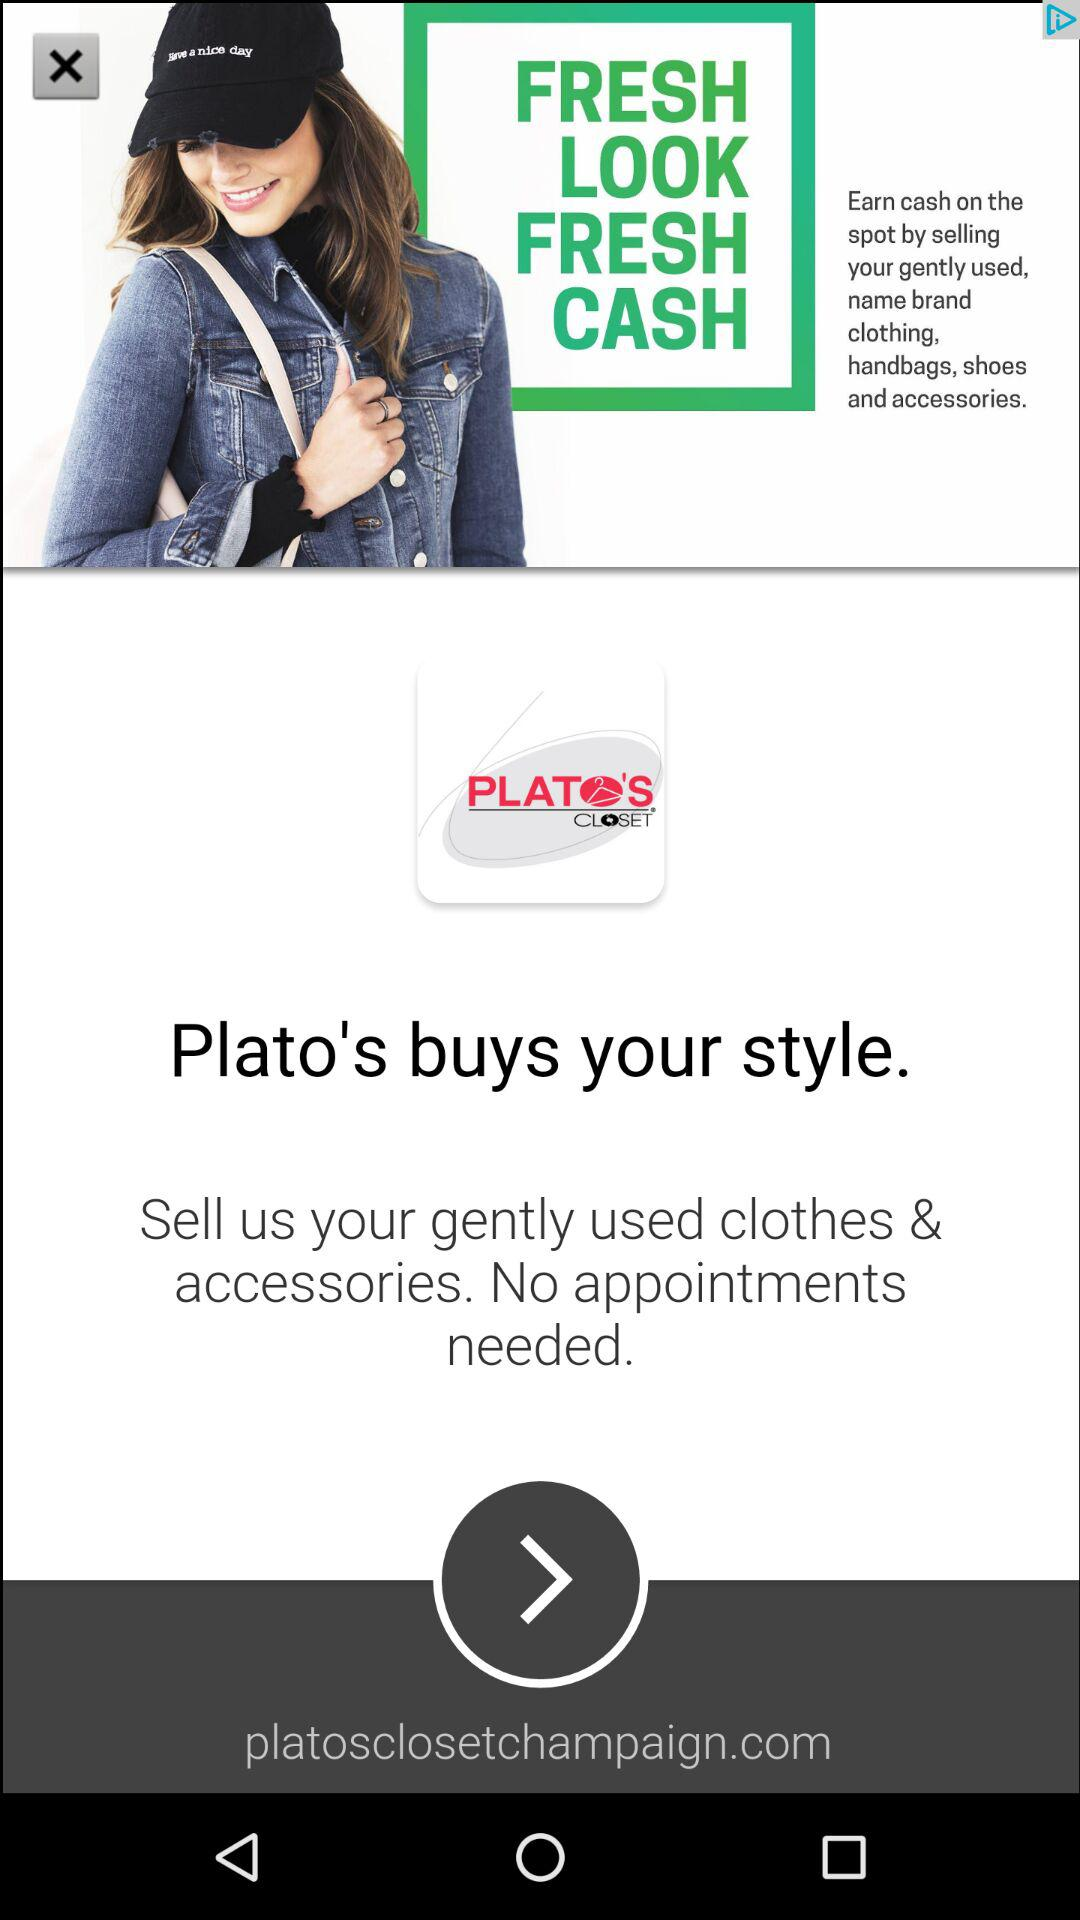What is the name of the application? The name of the application is "PLATO'S CLOSET". 